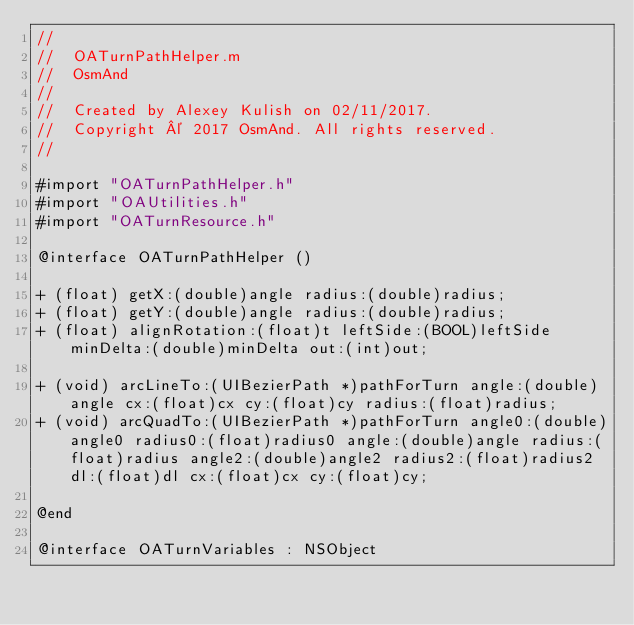<code> <loc_0><loc_0><loc_500><loc_500><_ObjectiveC_>//
//  OATurnPathHelper.m
//  OsmAnd
//
//  Created by Alexey Kulish on 02/11/2017.
//  Copyright © 2017 OsmAnd. All rights reserved.
//

#import "OATurnPathHelper.h"
#import "OAUtilities.h"
#import "OATurnResource.h"

@interface OATurnPathHelper ()

+ (float) getX:(double)angle radius:(double)radius;
+ (float) getY:(double)angle radius:(double)radius;
+ (float) alignRotation:(float)t leftSide:(BOOL)leftSide minDelta:(double)minDelta out:(int)out;

+ (void) arcLineTo:(UIBezierPath *)pathForTurn angle:(double)angle cx:(float)cx cy:(float)cy radius:(float)radius;
+ (void) arcQuadTo:(UIBezierPath *)pathForTurn angle0:(double)angle0 radius0:(float)radius0 angle:(double)angle radius:(float)radius angle2:(double)angle2 radius2:(float)radius2 dl:(float)dl cx:(float)cx cy:(float)cy;

@end

@interface OATurnVariables : NSObject
</code> 